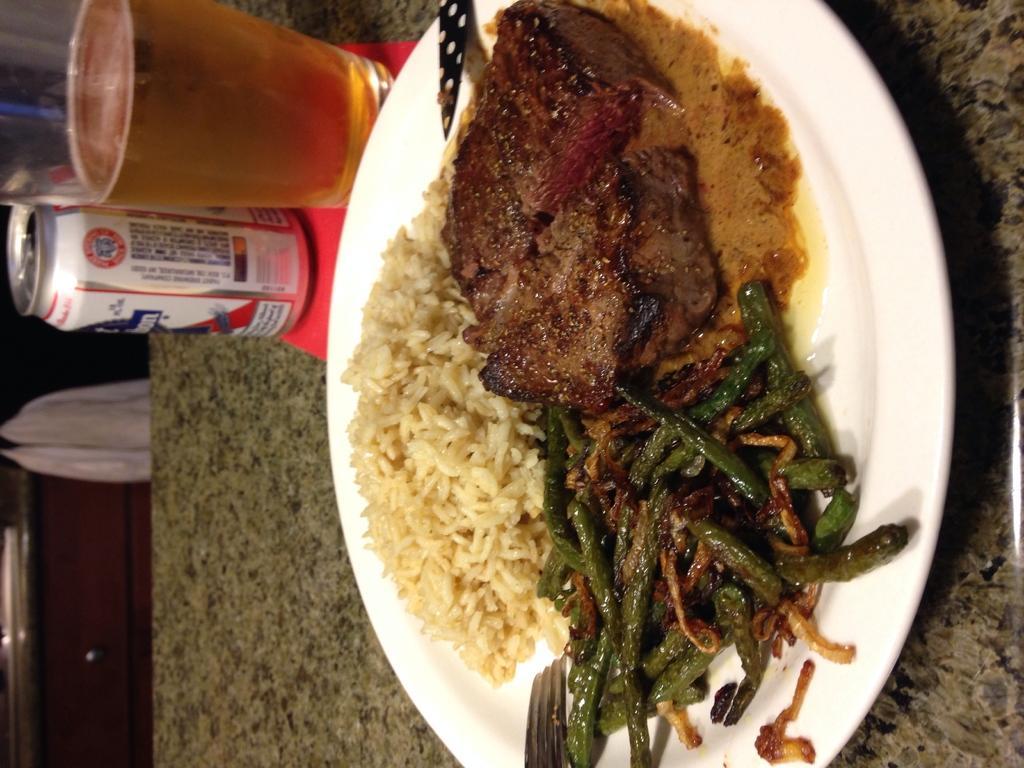Could you give a brief overview of what you see in this image? In the image on the right side there is a plate on the table with rice and some other food items. Behind the plate there is a glass with a drink and also there is a can. On the left corner of the image there is a cupboard and also there is a cloth. 